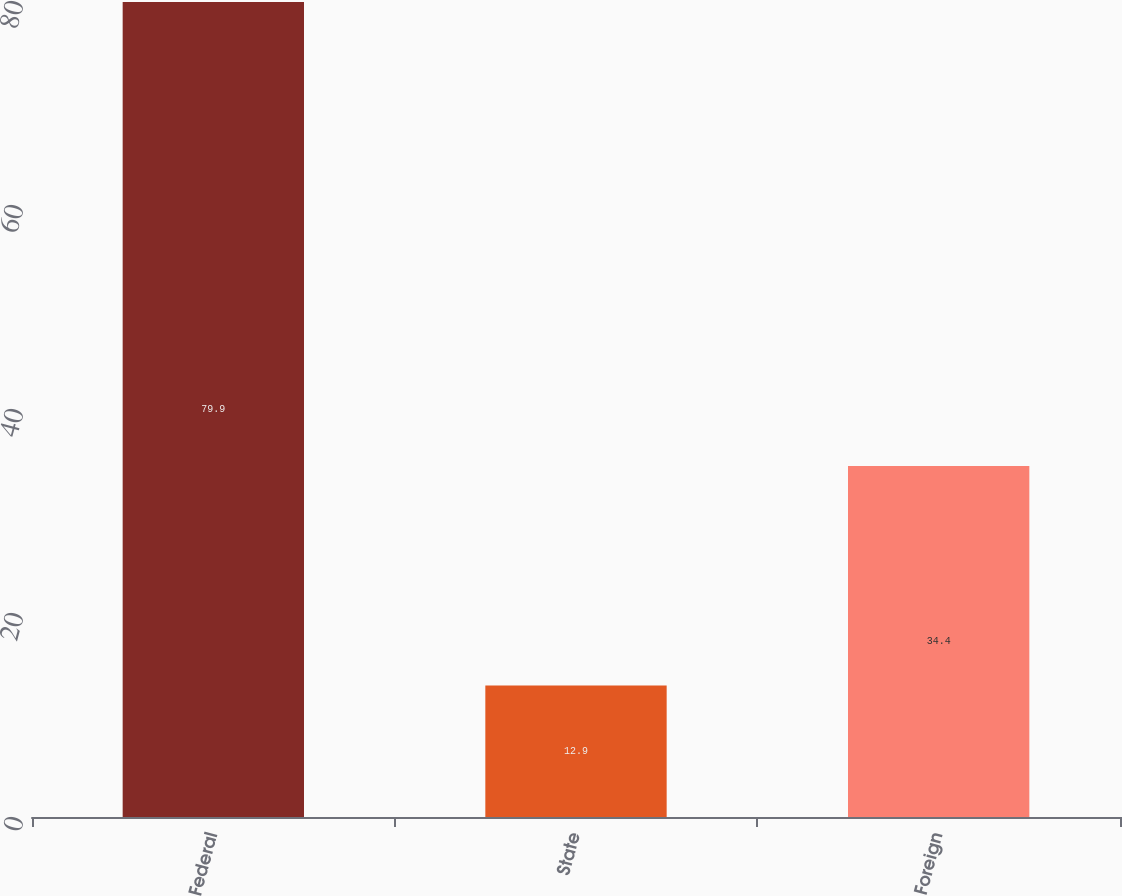<chart> <loc_0><loc_0><loc_500><loc_500><bar_chart><fcel>Federal<fcel>State<fcel>Foreign<nl><fcel>79.9<fcel>12.9<fcel>34.4<nl></chart> 